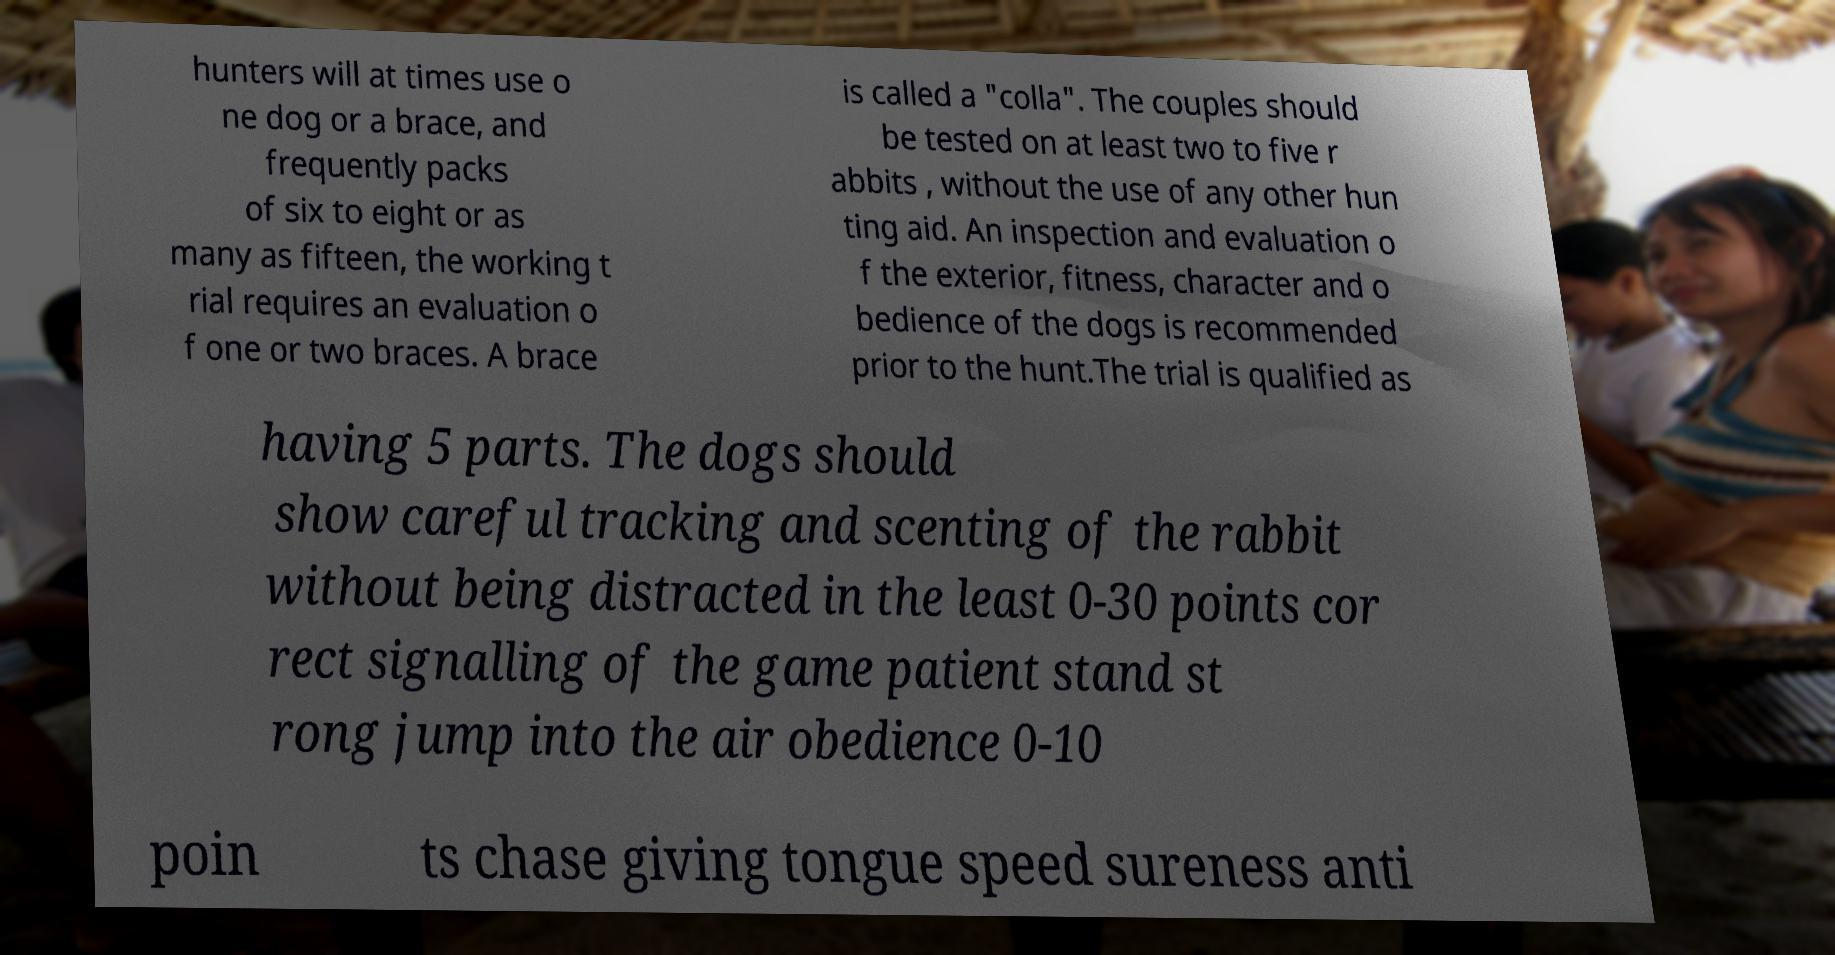I need the written content from this picture converted into text. Can you do that? hunters will at times use o ne dog or a brace, and frequently packs of six to eight or as many as fifteen, the working t rial requires an evaluation o f one or two braces. A brace is called a "colla". The couples should be tested on at least two to five r abbits , without the use of any other hun ting aid. An inspection and evaluation o f the exterior, fitness, character and o bedience of the dogs is recommended prior to the hunt.The trial is qualified as having 5 parts. The dogs should show careful tracking and scenting of the rabbit without being distracted in the least 0-30 points cor rect signalling of the game patient stand st rong jump into the air obedience 0-10 poin ts chase giving tongue speed sureness anti 